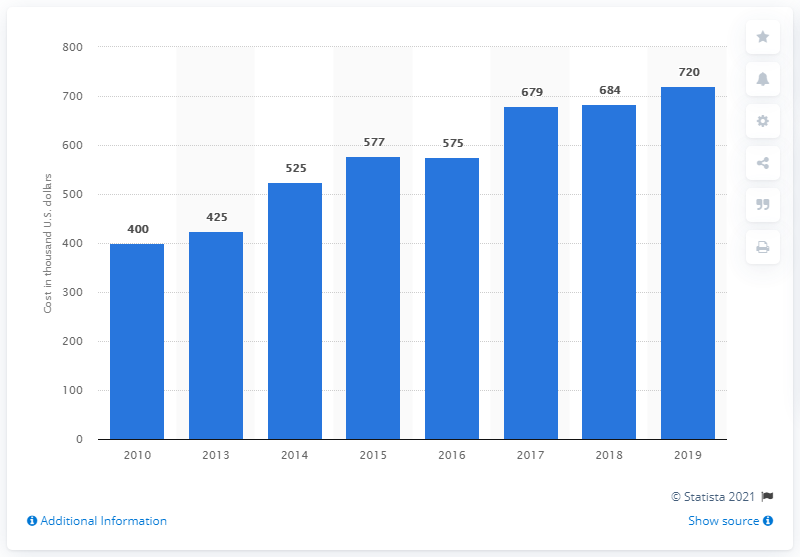Outline some significant characteristics in this image. The cost of a 30-second spot a year earlier was 684. The average cost of a 30-second TV commercial during the 76th Golden Globes was 720.. 